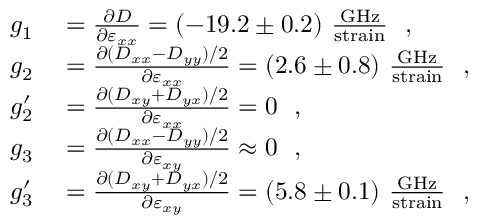<formula> <loc_0><loc_0><loc_500><loc_500>\begin{array} { r l } { g _ { 1 } } & = \frac { \partial D } { \partial \varepsilon _ { x x } } = ( - 1 9 . 2 \pm 0 . 2 ) \frac { G H z } { s t r a i n } \ , } \\ { g _ { 2 } } & = \frac { \partial ( D _ { x x } - D _ { y y } ) / 2 } { \partial \varepsilon _ { x x } } = ( 2 . 6 \pm 0 . 8 ) \frac { G H z } { s t r a i n } \ , } \\ { g _ { 2 } ^ { \prime } } & = \frac { \partial ( D _ { x y } + D _ { y x } ) / 2 } { \partial \varepsilon _ { x x } } = 0 \ , } \\ { g _ { 3 } } & = \frac { \partial ( D _ { x x } - D _ { y y } ) / 2 } { \partial \varepsilon _ { x y } } \approx 0 \ , } \\ { g _ { 3 } ^ { \prime } } & = \frac { \partial ( D _ { x y } + D _ { y x } ) / 2 } { \partial \varepsilon _ { x y } } = ( 5 . 8 \pm 0 . 1 ) \frac { G H z } { s t r a i n } \ , } \end{array}</formula> 